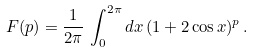Convert formula to latex. <formula><loc_0><loc_0><loc_500><loc_500>F ( p ) = \frac { 1 } { 2 \pi } \, \int _ { 0 } ^ { 2 \pi } d x \, ( 1 + 2 \cos x ) ^ { p } \, .</formula> 